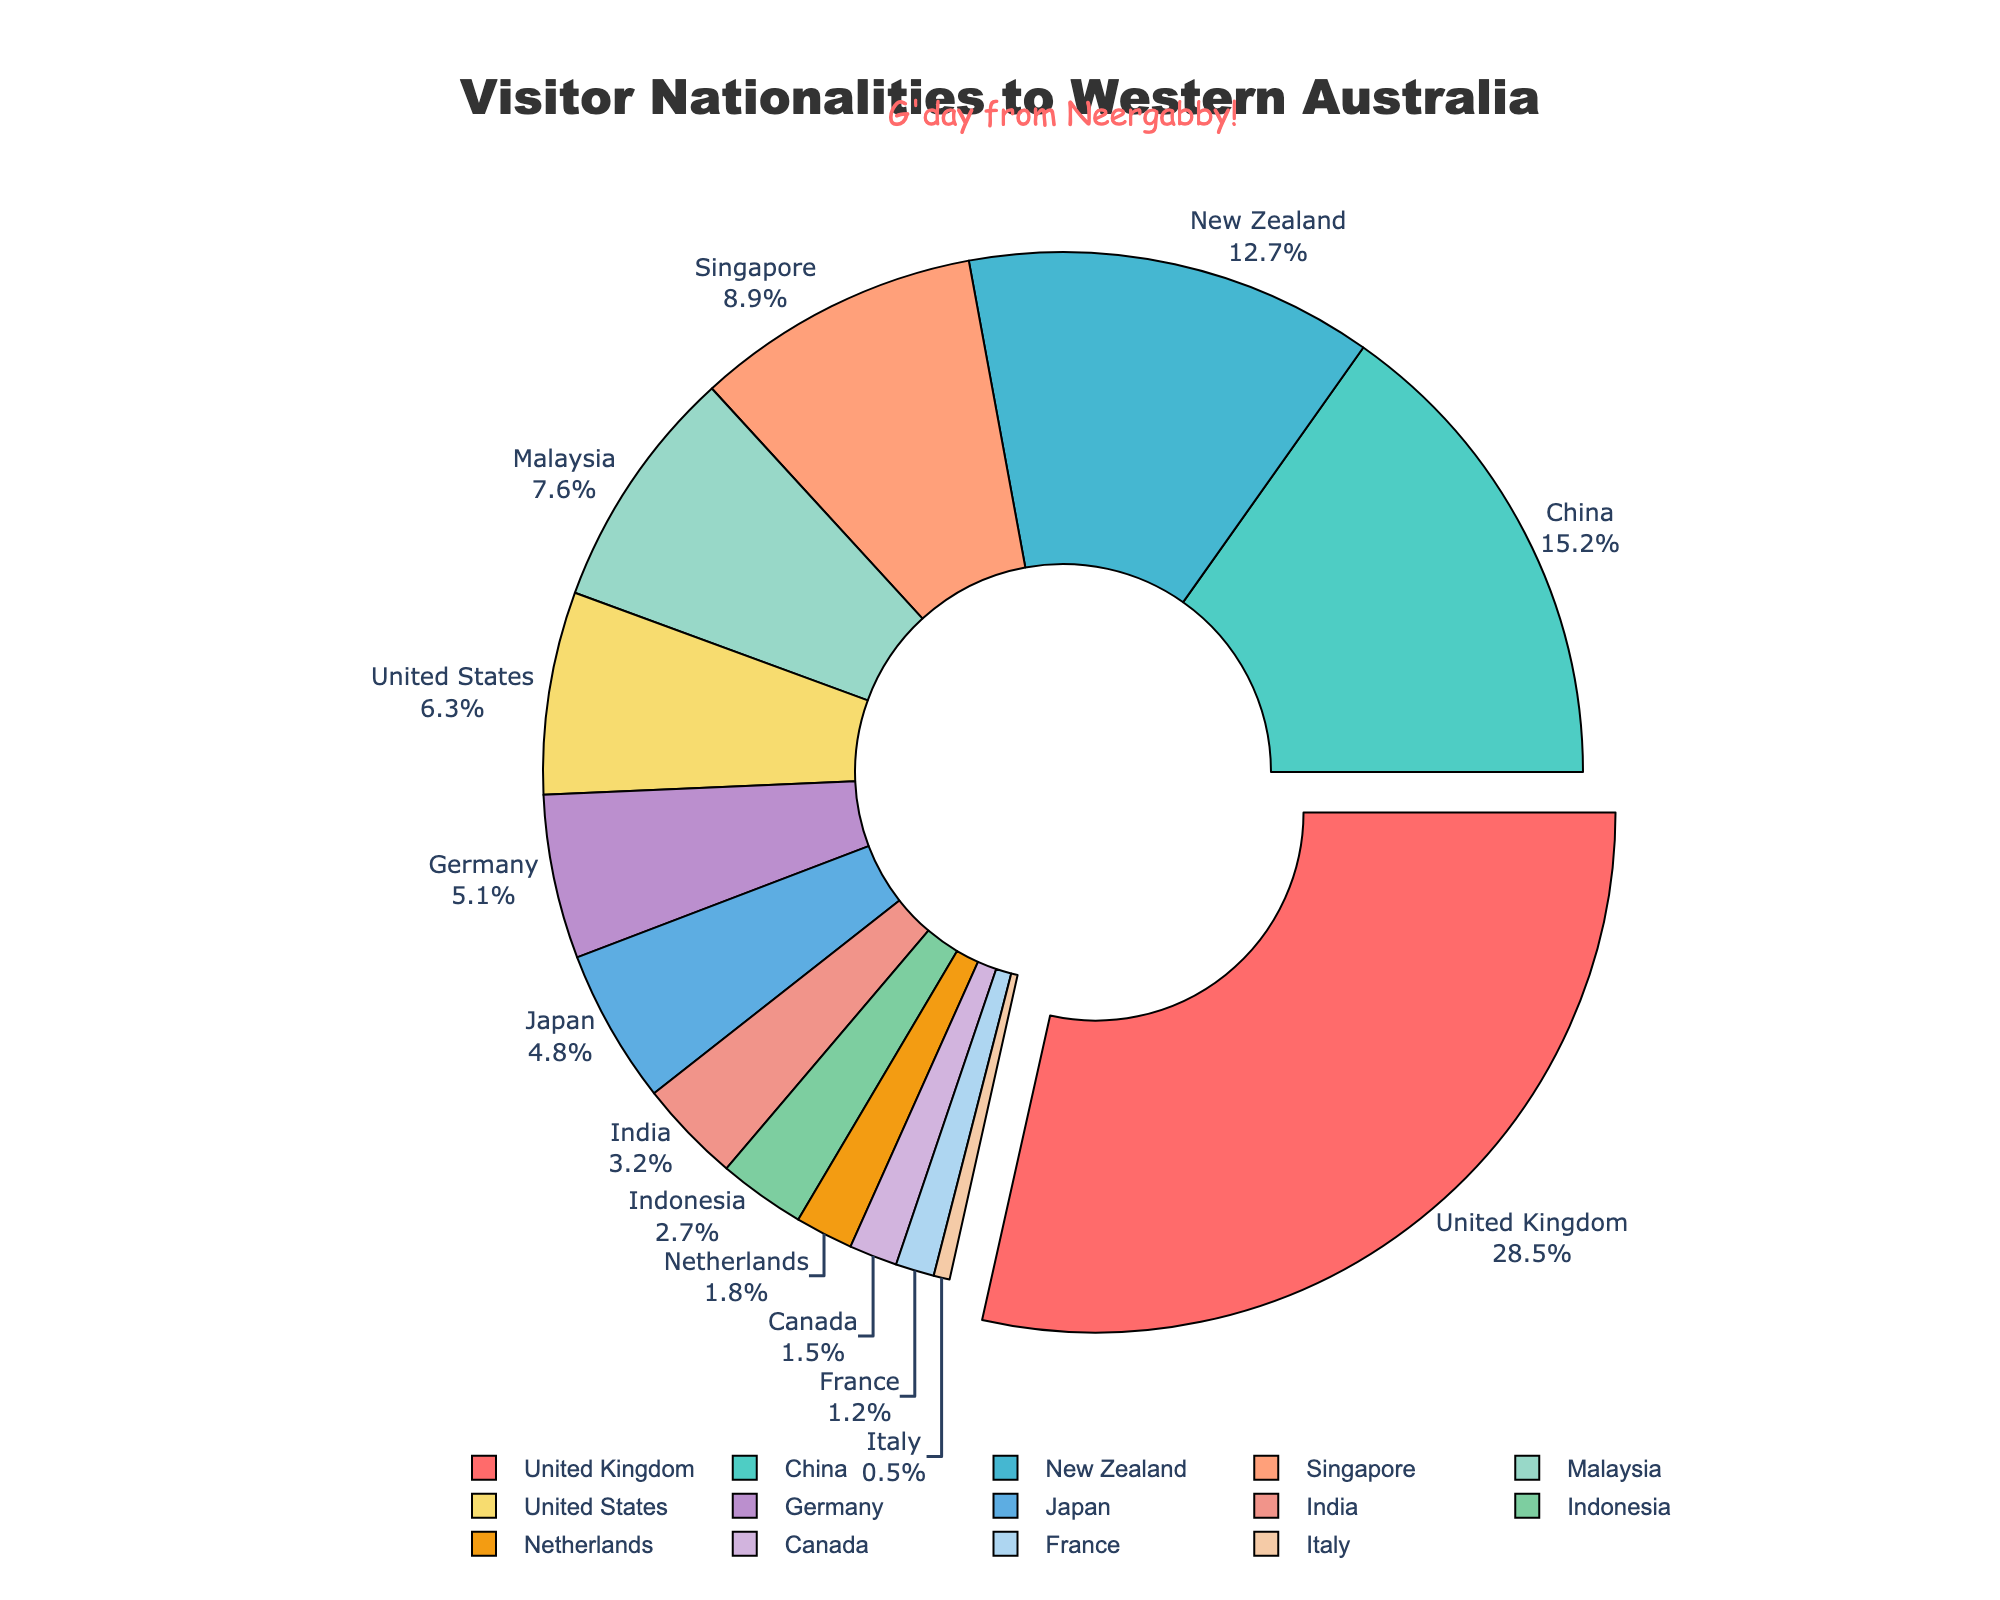what is the percentage of visitors from Germany? Find the data value associated with Germany on the pie chart. The percentage listed is 5.1%
Answer: 5.1% Which country contributes the highest number of visitors to Western Australia? Look for the segment in the pie chart with the largest percentage. United Kingdom has the highest percentage at 28.5%
Answer: United Kingdom How does the percentage of visitors from China compare to those from the United States? Find the percentages for both China and the United States on the pie chart. China has 15.2% and the United States has 6.3%. Comparing the numbers, China has a higher percentage
Answer: China has a higher percentage What is the combined percentage of visitors from New Zealand, Singapore, and Malaysia? Find the percentages for New Zealand (12.7%), Singapore (8.9%), and Malaysia (7.6%). Adding them together: 12.7 + 8.9 + 7.6 = 29.2%
Answer: 29.2% How much more percentage do visitors from the United Kingdom contribute compared to those from Japan? Find the percentages for the United Kingdom (28.5%) and Japan (4.8%). Subtract Japan's percentage from that of the United Kingdom: 28.5 - 4.8 = 23.7%
Answer: 23.7% What's the median value of visitor percentages? First, list all the percentages in ascending order: 0.5, 1.2, 1.5, 1.8, 2.7, 3.2, 4.8, 5.1, 6.3, 7.6, 8.9, 12.7, 15.2, 28.5. Since there are 14 values, the median is the average of the 7th and 8th values: (4.8 + 5.1) / 2 = 4.95%
Answer: 4.95% What color is associated with the slice representing visitors from the United States? Identify the color of the slice marked 'United States' on the pie chart; it is typically the color closest to the label. The color is #F7DC6F (yellow)
Answer: yellow 